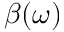<formula> <loc_0><loc_0><loc_500><loc_500>\beta ( \omega )</formula> 